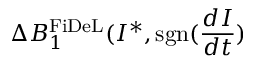Convert formula to latex. <formula><loc_0><loc_0><loc_500><loc_500>\Delta B _ { 1 } ^ { F i D e L } ( I ^ { * } , s g n ( \frac { d I } { d t } )</formula> 